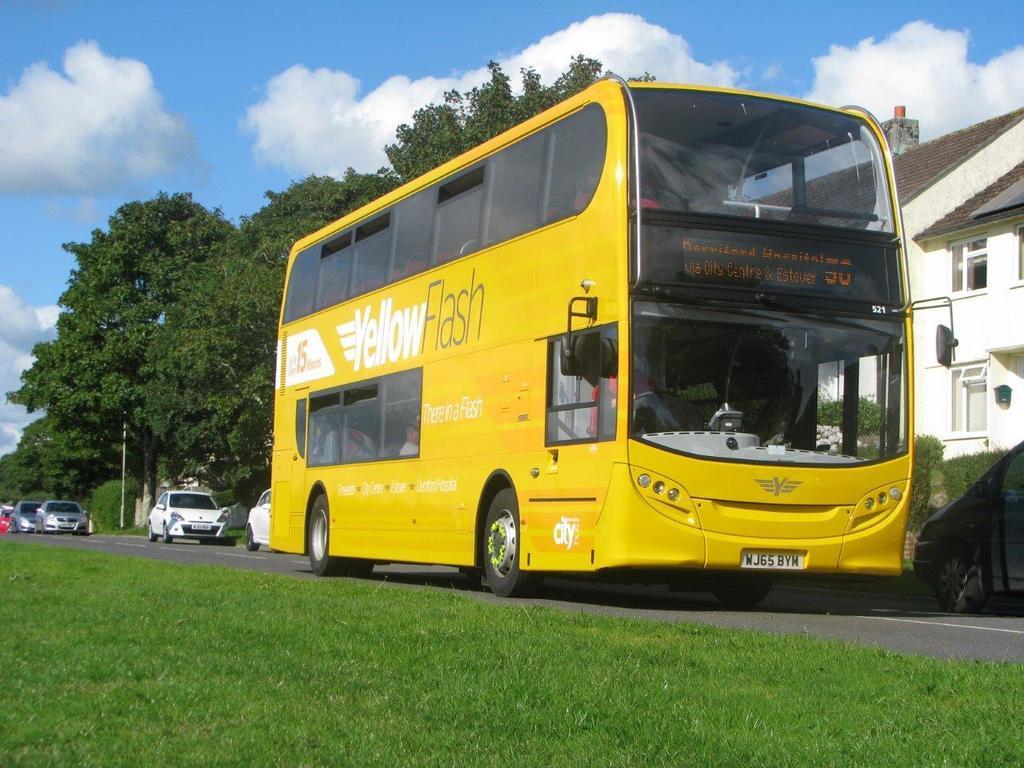Can you describe this image briefly? In the image there is a yellow color double decker bus going on the road with cars going behind it, in the front its grassland and behind it there is a home on the right side and trees on the left side and above its sky with clouds. 